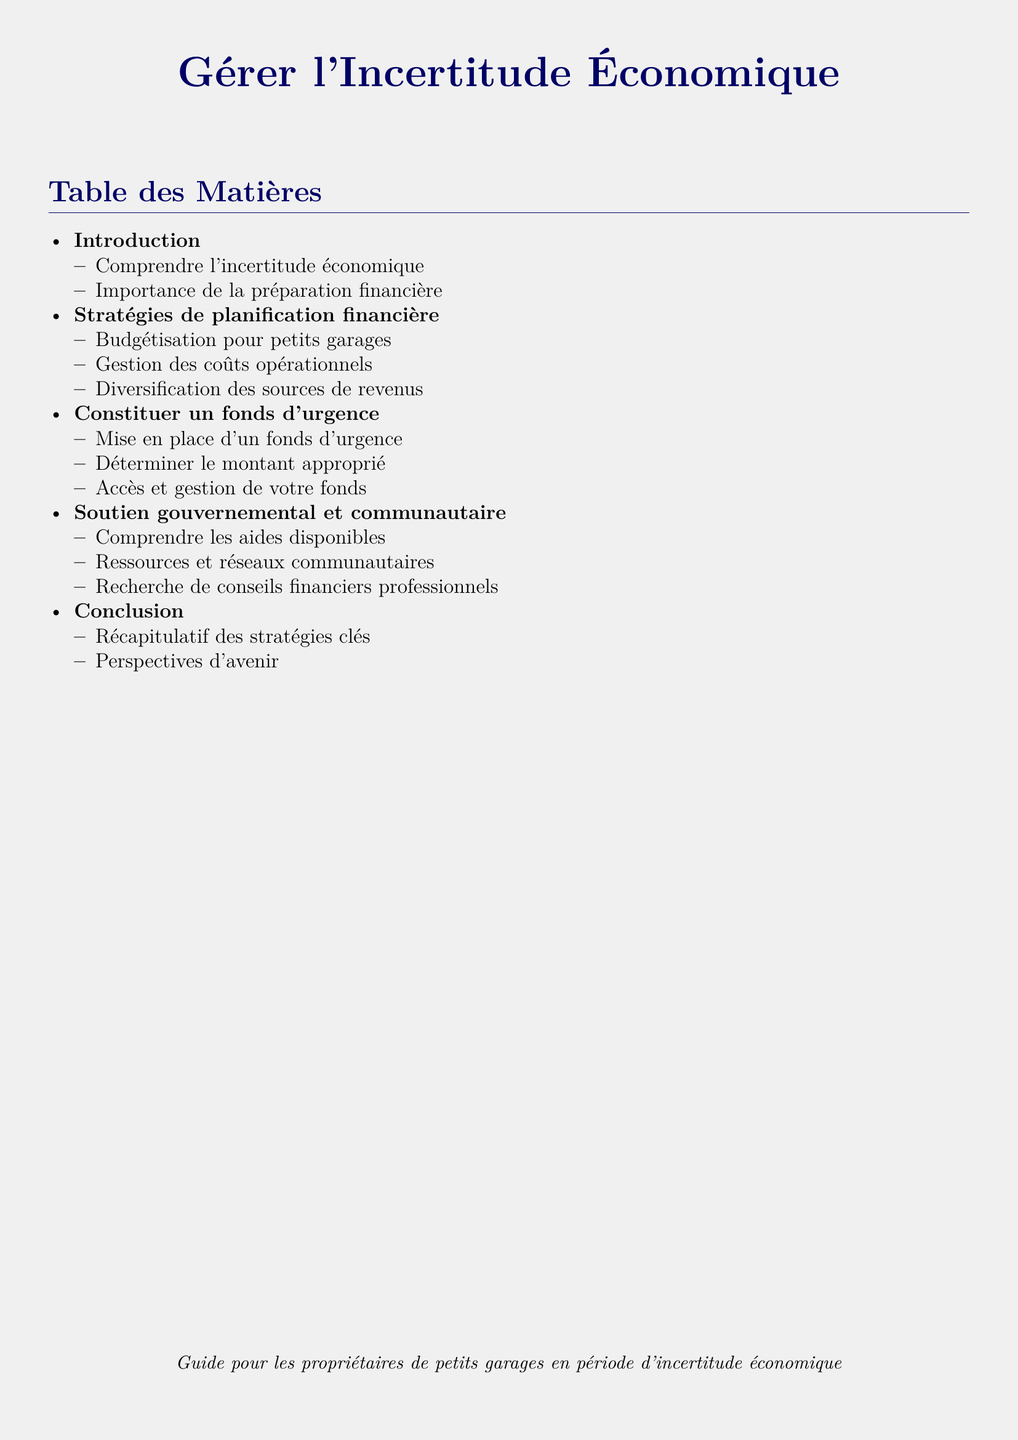What is the first topic in the table of contents? The first topic listed is "Introduction," which signifies the beginning of the document's subject matter.
Answer: Introduction How many sections are there in the document? The document contains five main sections as outlined in the table of contents.
Answer: Five What is a key aspect of the financial planning strategies mentioned? The document outlines budget management for small garages as a specific strategy within financial planning.
Answer: Budgétisation pour petits garages What is the recommended action for creating an emergency fund? The document suggests the "Mise en place d'un fonds d'urgence" as a primary recommendation for establishing a financial safety net.
Answer: Mise en place d'un fonds d'urgence What type of support is discussed in the document? The document explores government and community support as a crucial resource for individuals facing economic uncertainty.
Answer: Soutien gouvernemental et communautaire What is included in the conclusion section? The conclusion summarizes key strategies and provides insights into future expectations based on the preceding information.
Answer: Récapitulatif des stratégies clés What resources can be found in the document? The document mentions various resources and community networks available for assistance during challenging economic times.
Answer: Ressources et réseaux communautaires 